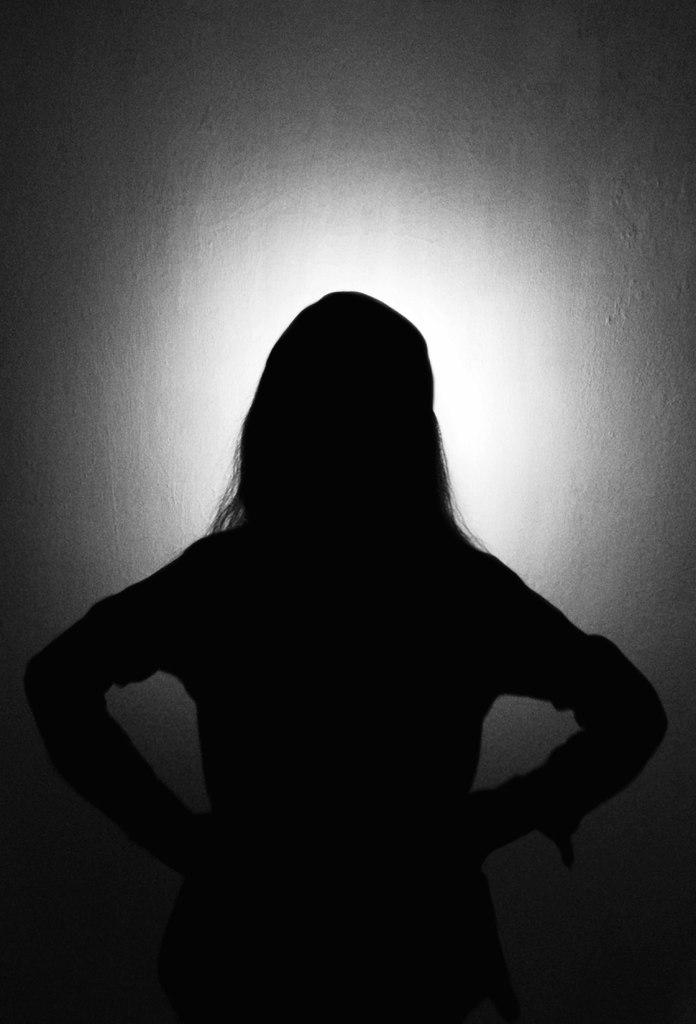What is the main subject of the image? There is a person in the image. What color scheme is used in the image? The image is in black and white. How many tickets does the person have in the image? There is no mention of tickets in the image, so we cannot determine how many the person has. 